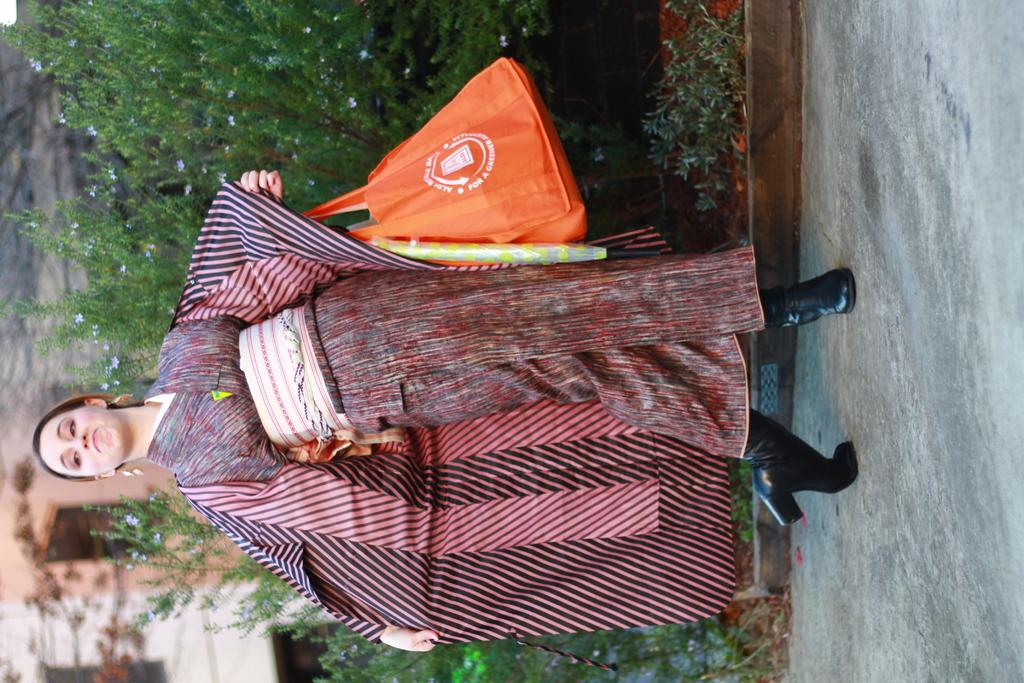Who is present in the image? There is a woman in the image. What is the woman doing in the image? The woman is standing in the image. What is the woman holding in the image? The woman is holding a bag in the image. What can be seen in the background of the image? There are trees and a building in the background of the image. What type of substance is being cooked in the oven in the image? There is no oven present in the image, so it is not possible to determine what, if any, substance might be cooking. 